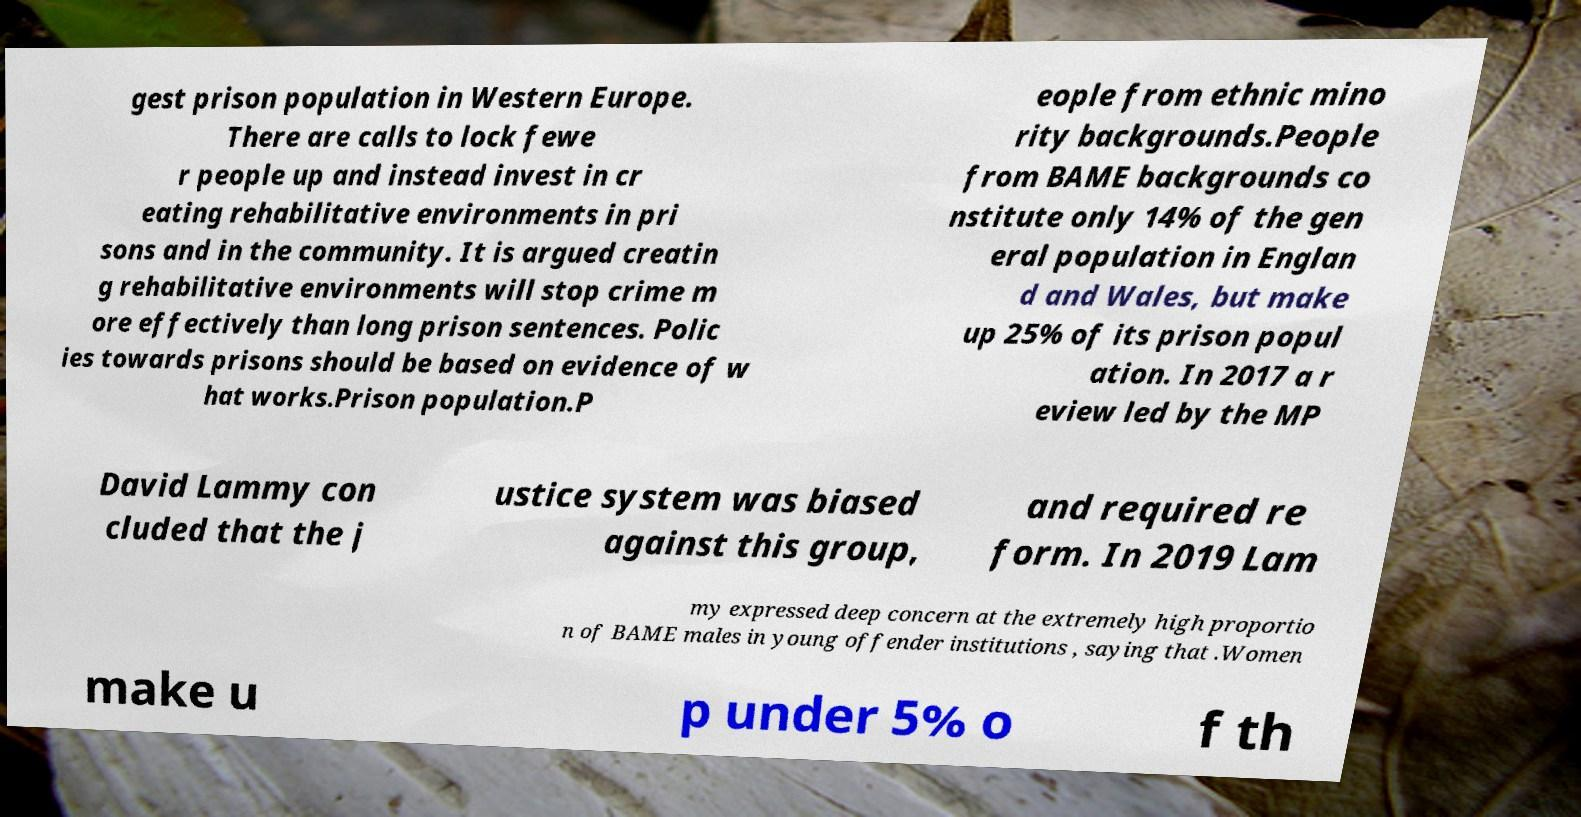Could you assist in decoding the text presented in this image and type it out clearly? gest prison population in Western Europe. There are calls to lock fewe r people up and instead invest in cr eating rehabilitative environments in pri sons and in the community. It is argued creatin g rehabilitative environments will stop crime m ore effectively than long prison sentences. Polic ies towards prisons should be based on evidence of w hat works.Prison population.P eople from ethnic mino rity backgrounds.People from BAME backgrounds co nstitute only 14% of the gen eral population in Englan d and Wales, but make up 25% of its prison popul ation. In 2017 a r eview led by the MP David Lammy con cluded that the j ustice system was biased against this group, and required re form. In 2019 Lam my expressed deep concern at the extremely high proportio n of BAME males in young offender institutions , saying that .Women make u p under 5% o f th 